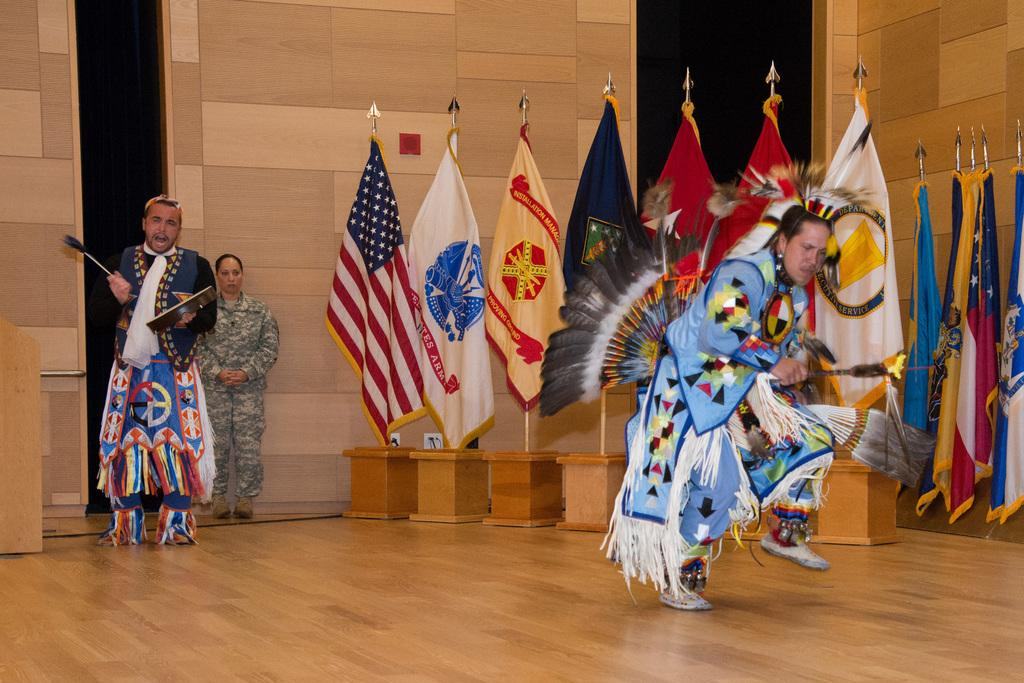What are the people in the image wearing? The people in the image are wearing clothes and shoes. What is the material of the floor in the image? The floor in the image is wooden. What is the material of the walls in the image? The walls in the image are also wooden. What can be seen representing different nations in the image? There are flags of countries in the image. What type of natural material is present in the image? There are feathers in the image. What object made of wood can be seen in the image? There is a wooden box in the image. How does the aunt in the image maintain a quiet atmosphere? There is no mention of an aunt in the image, so we cannot determine how she might maintain a quiet atmosphere. 